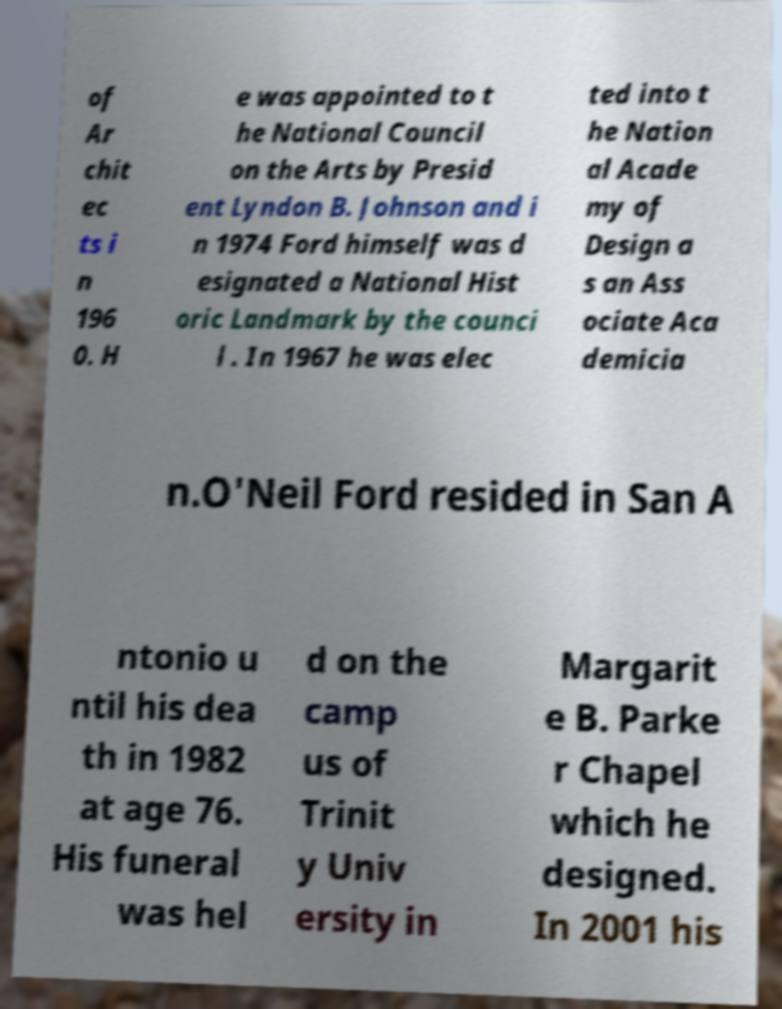Can you read and provide the text displayed in the image?This photo seems to have some interesting text. Can you extract and type it out for me? of Ar chit ec ts i n 196 0. H e was appointed to t he National Council on the Arts by Presid ent Lyndon B. Johnson and i n 1974 Ford himself was d esignated a National Hist oric Landmark by the counci l . In 1967 he was elec ted into t he Nation al Acade my of Design a s an Ass ociate Aca demicia n.O'Neil Ford resided in San A ntonio u ntil his dea th in 1982 at age 76. His funeral was hel d on the camp us of Trinit y Univ ersity in Margarit e B. Parke r Chapel which he designed. In 2001 his 